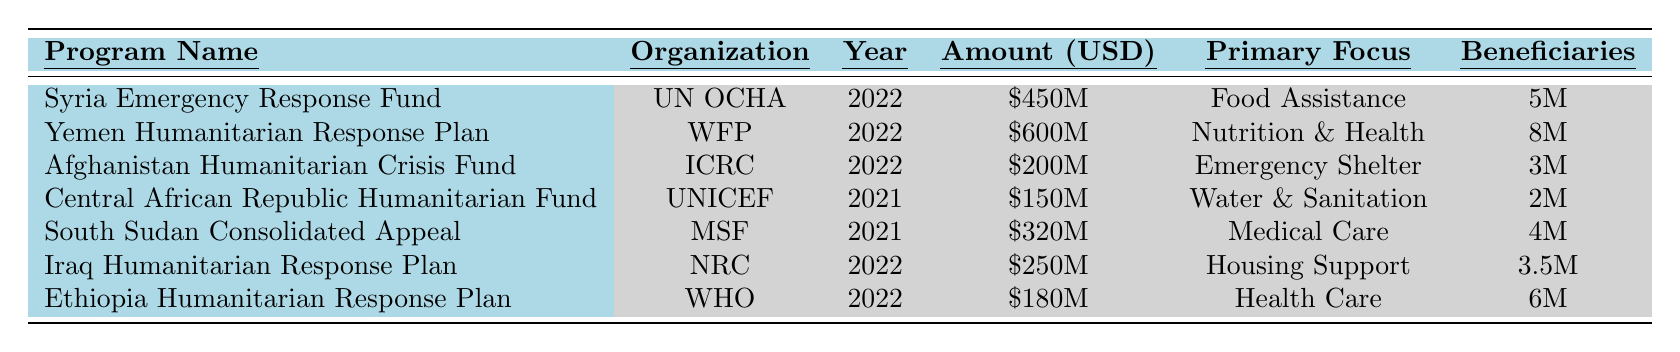What is the total amount allocated for humanitarian aid programs in 2022? By adding the amounts allocated in 2022: $450M (Syria) + $600M (Yemen) + $200M (Afghanistan) + $250M (Iraq) + $180M (Ethiopia) = $1,680M.
Answer: $1.68 billion Which organization received the highest funding allocation in 2022? The World Food Programme (WFP) received the highest allocation in 2022 with $600M for the Yemen Humanitarian Response Plan.
Answer: WFP How many beneficiaries are targeted by the Syria Emergency Response Fund? The table indicates that the Syria Emergency Response Fund targets 5 million beneficiaries.
Answer: 5 million What is the primary focus of the Afghanistan Humanitarian Crisis Fund? The primary focus of the Afghanistan Humanitarian Crisis Fund is on Emergency Shelter and Non-Food Items.
Answer: Emergency Shelter and Non-Food Items What is the average amount allocated per beneficiary for the Yemen Humanitarian Response Plan? The amount allocated is $600M for 8 million beneficiaries, so the average is $600M / 8M = $75,000 per beneficiary.
Answer: $75,000 Is the total funding for the Central African Republic Humanitarian Fund greater than $200M? The funding allocated for the Central African Republic Humanitarian Fund is $150M, which is less than $200M.
Answer: No What was the total number of beneficiaries for all programs listed in 2021? The total for 2021 is 2M (CAR) + 4M (South Sudan) = 6M beneficiaries.
Answer: 6 million Which program has the lowest funding allocation and what is the amount? The program with the lowest funding allocation is the Central African Republic Humanitarian Fund, which has $150M allocated.
Answer: Central African Republic Humanitarian Fund, $150 million How much more funding did the Yemen Humanitarian Response Plan receive compared to the Afghanistan Humanitarian Crisis Fund? The difference in funding is $600M (Yemen) - $200M (Afghanistan) = $400M more for Yemen.
Answer: $400 million In which year did the South Sudan Consolidated Appeal receive funding? The South Sudan Consolidated Appeal received funding in 2021 according to the table.
Answer: 2021 